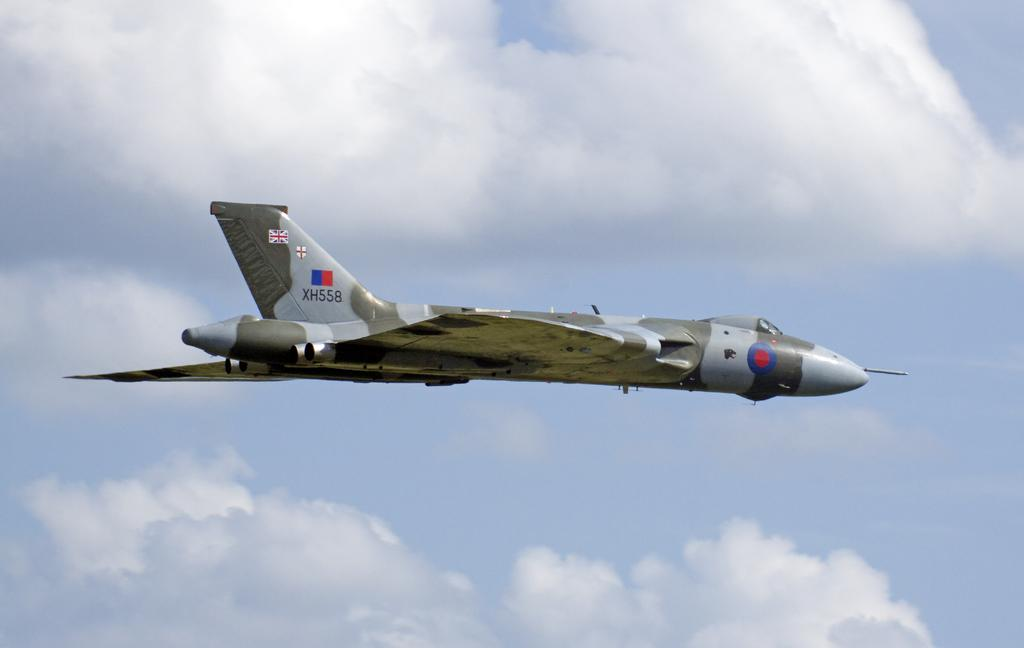What is the main subject of the image? The main subject of the image is a flying aircraft. How would you describe the sky in the image? The sky is blue and cloudy in the image. What type of poison is being used to clean the sidewalk in the image? There is no sidewalk or poison present in the image. Can you tell me the credit score of the person in the image? There is no person in the image, and therefore no credit score can be determined. 